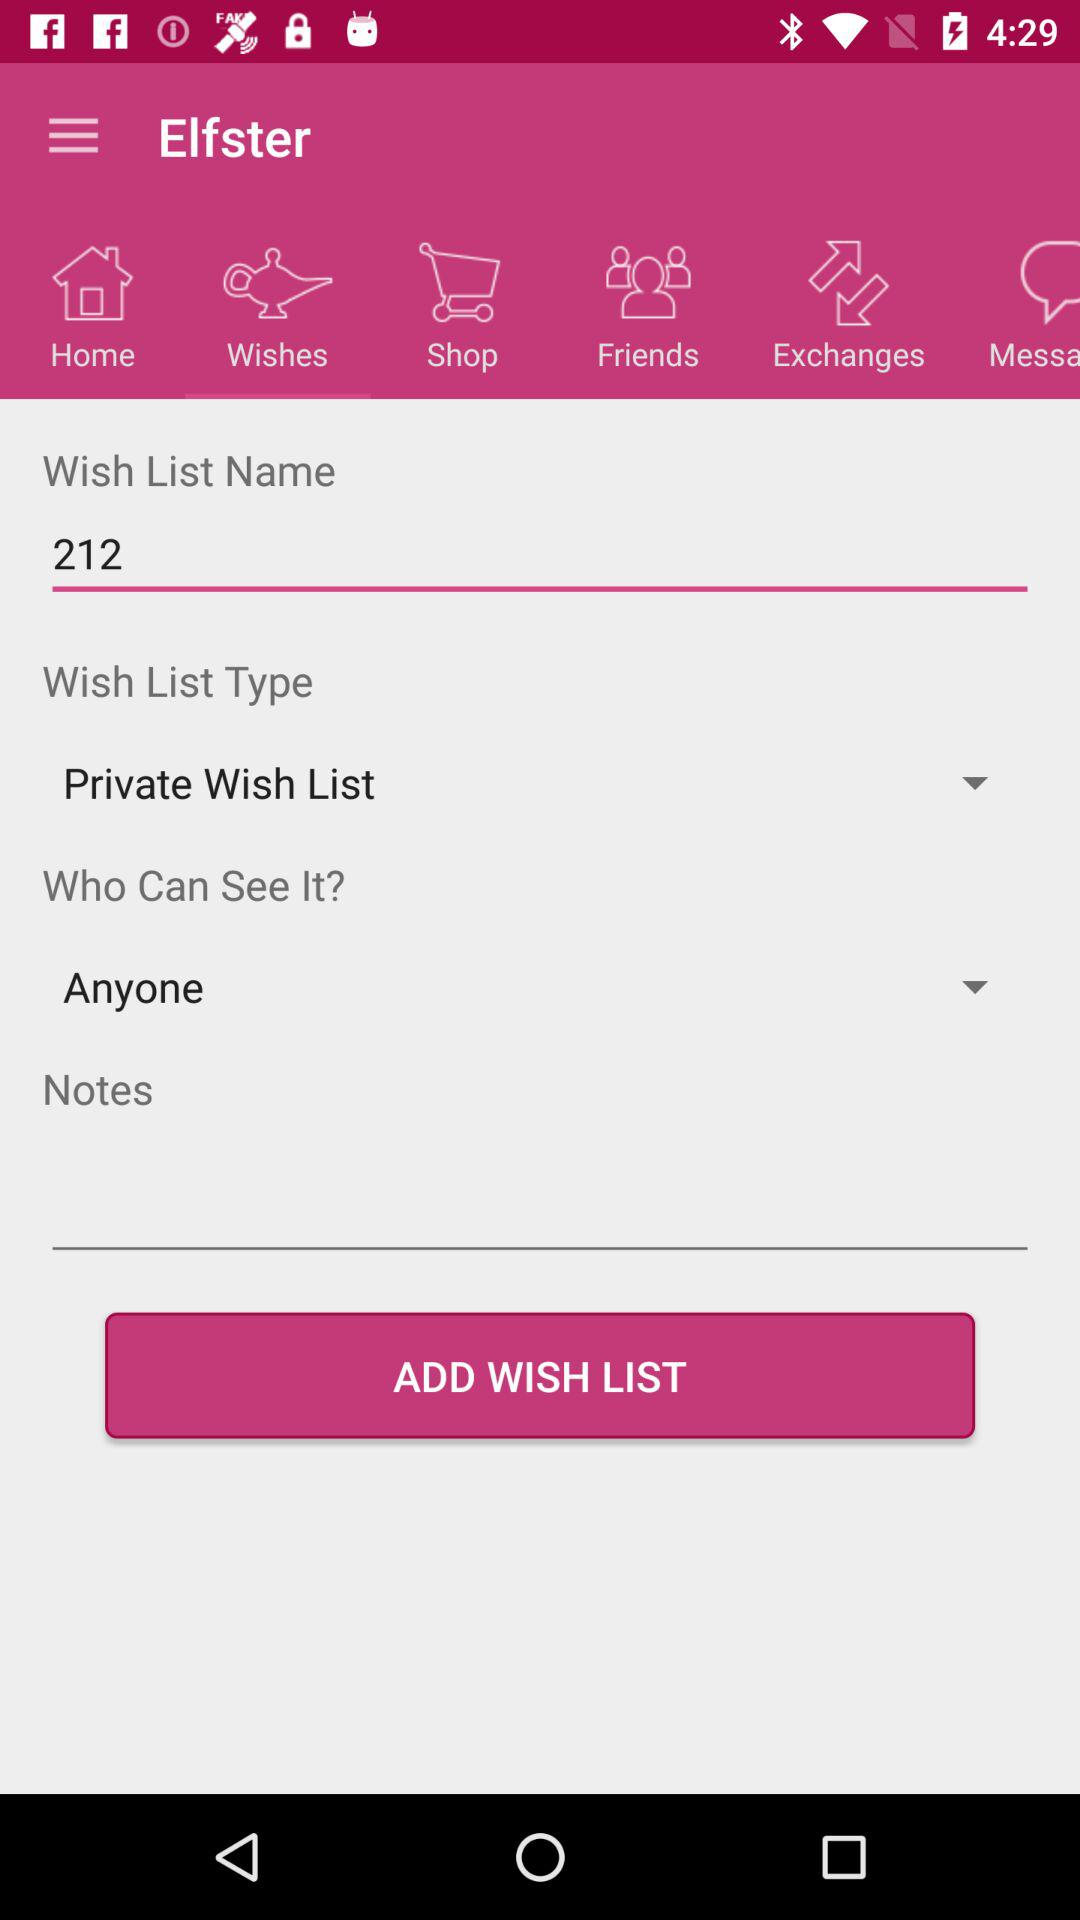What is the name of the wish list? The name of the wish list is 212. 